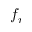<formula> <loc_0><loc_0><loc_500><loc_500>f _ { r }</formula> 